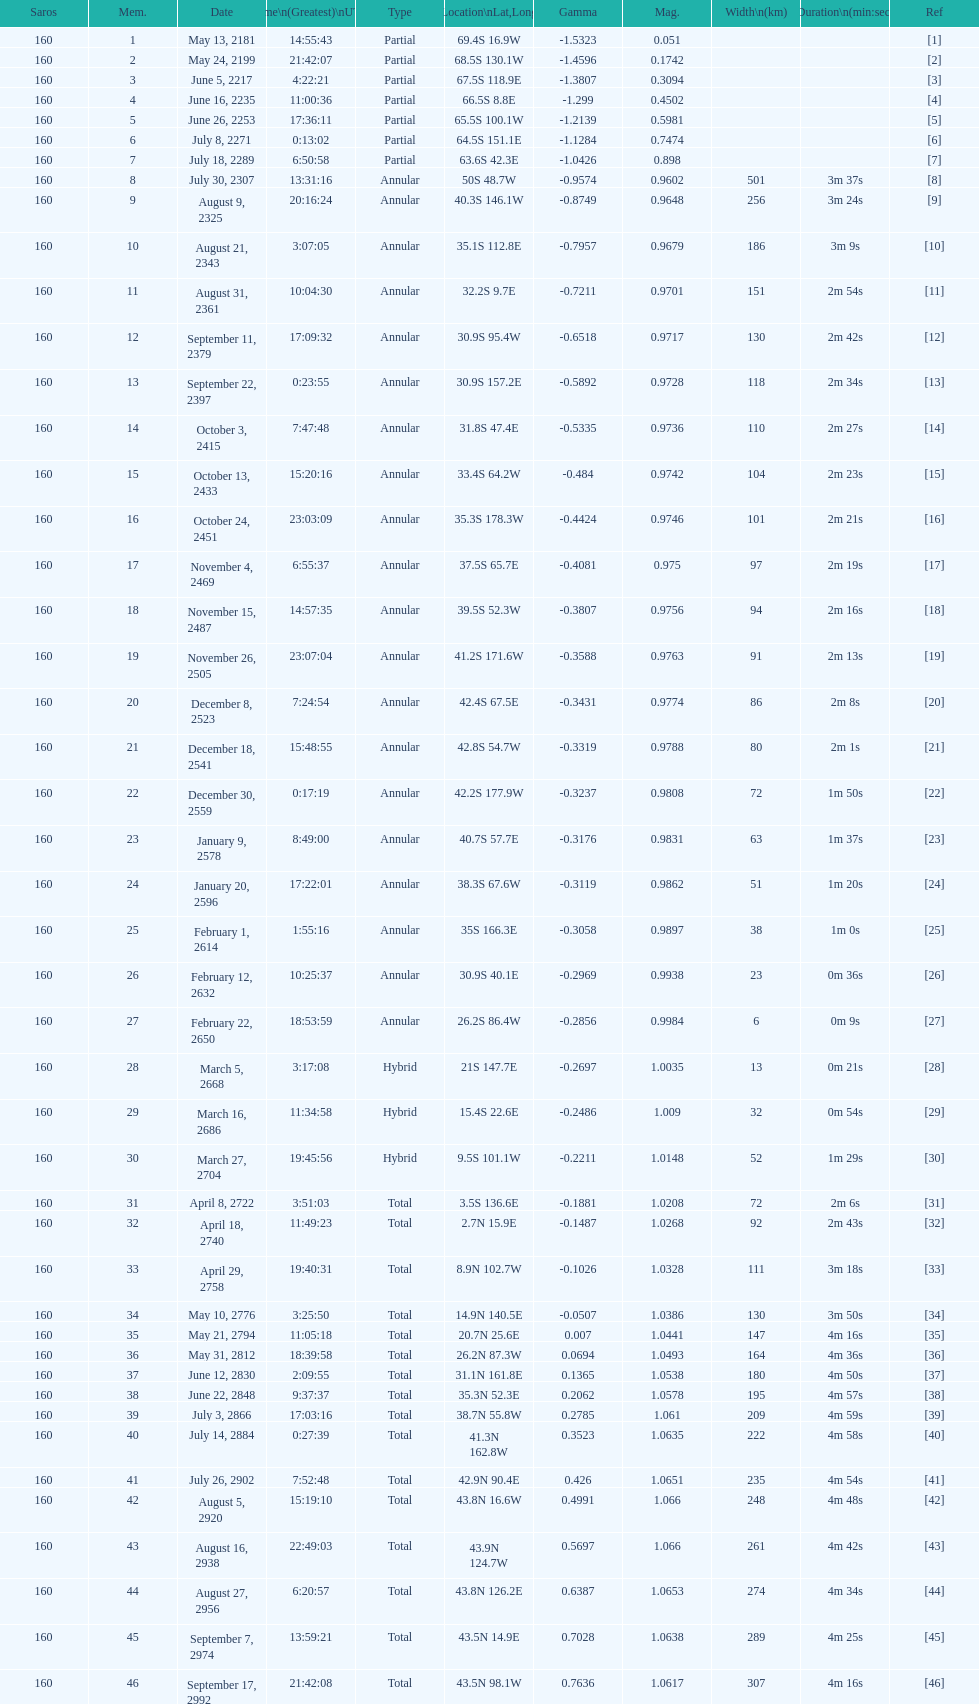How long did 18 last? 2m 16s. 